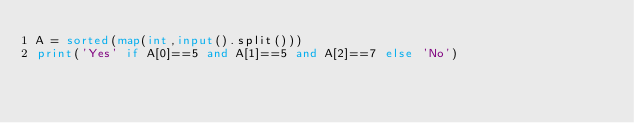Convert code to text. <code><loc_0><loc_0><loc_500><loc_500><_Python_>A = sorted(map(int,input().split()))
print('Yes' if A[0]==5 and A[1]==5 and A[2]==7 else 'No')
</code> 